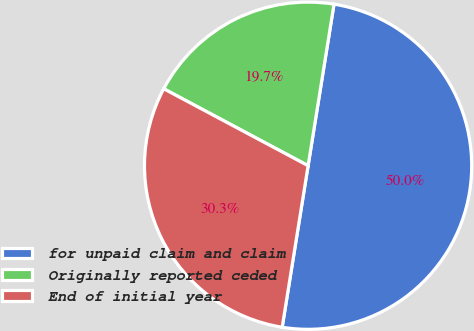Convert chart. <chart><loc_0><loc_0><loc_500><loc_500><pie_chart><fcel>for unpaid claim and claim<fcel>Originally reported ceded<fcel>End of initial year<nl><fcel>50.0%<fcel>19.74%<fcel>30.26%<nl></chart> 